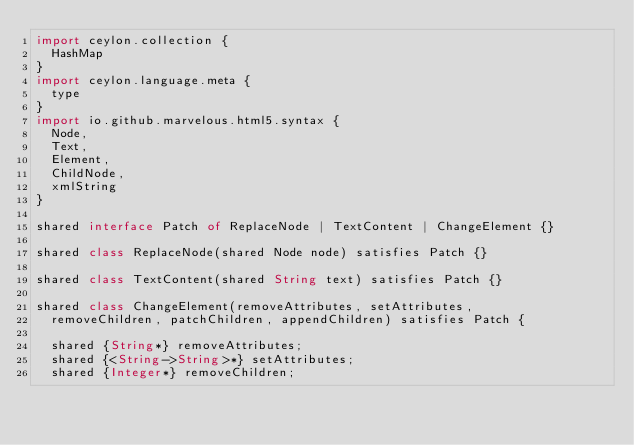Convert code to text. <code><loc_0><loc_0><loc_500><loc_500><_Ceylon_>import ceylon.collection {
	HashMap
}
import ceylon.language.meta {
	type
}
import io.github.marvelous.html5.syntax {
	Node,
	Text,
	Element,
	ChildNode,
	xmlString
}

shared interface Patch of ReplaceNode | TextContent | ChangeElement {}

shared class ReplaceNode(shared Node node) satisfies Patch {}

shared class TextContent(shared String text) satisfies Patch {}

shared class ChangeElement(removeAttributes, setAttributes,
	removeChildren, patchChildren, appendChildren) satisfies Patch {
	
	shared {String*} removeAttributes;
	shared {<String->String>*} setAttributes;
	shared {Integer*} removeChildren;</code> 